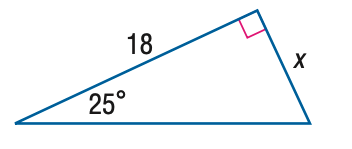Question: Find x to the nearest hundredth.
Choices:
A. 7.61
B. 8.39
C. 16.31
D. 18.00
Answer with the letter. Answer: B 